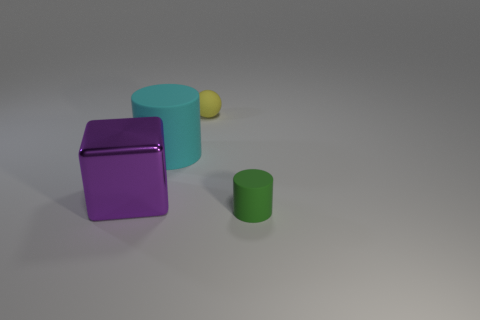Is there a green matte cylinder?
Offer a terse response. Yes. Is there any other thing that has the same material as the green cylinder?
Provide a succinct answer. Yes. Are there any yellow cylinders made of the same material as the cyan cylinder?
Provide a short and direct response. No. There is a green cylinder that is the same size as the yellow thing; what is its material?
Provide a succinct answer. Rubber. What number of other small rubber objects are the same shape as the tiny yellow matte thing?
Ensure brevity in your answer.  0. There is a green thing that is made of the same material as the yellow ball; what size is it?
Your answer should be compact. Small. The object that is on the right side of the cyan cylinder and behind the small green rubber cylinder is made of what material?
Ensure brevity in your answer.  Rubber. What number of green matte cylinders have the same size as the matte ball?
Your answer should be compact. 1. What material is the other small thing that is the same shape as the cyan matte object?
Your answer should be compact. Rubber. How many things are either tiny objects that are in front of the large cyan cylinder or small things on the left side of the green thing?
Your answer should be very brief. 2. 